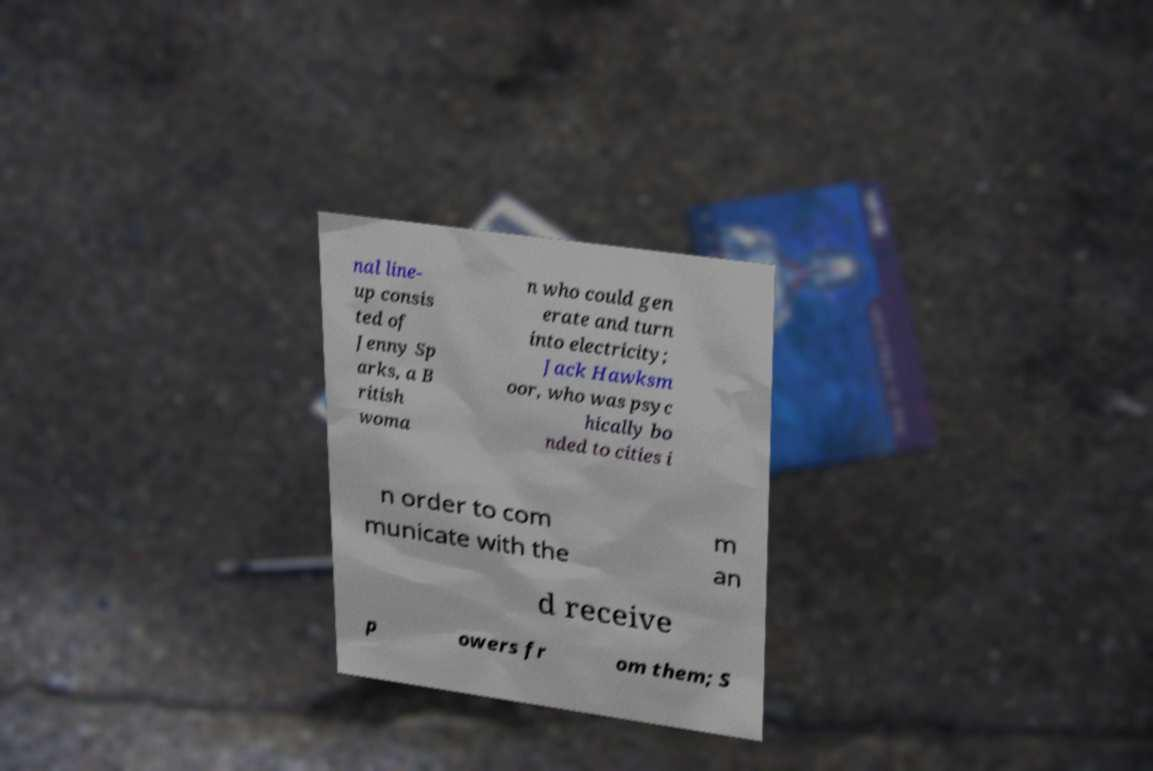Please identify and transcribe the text found in this image. nal line- up consis ted of Jenny Sp arks, a B ritish woma n who could gen erate and turn into electricity; Jack Hawksm oor, who was psyc hically bo nded to cities i n order to com municate with the m an d receive p owers fr om them; S 